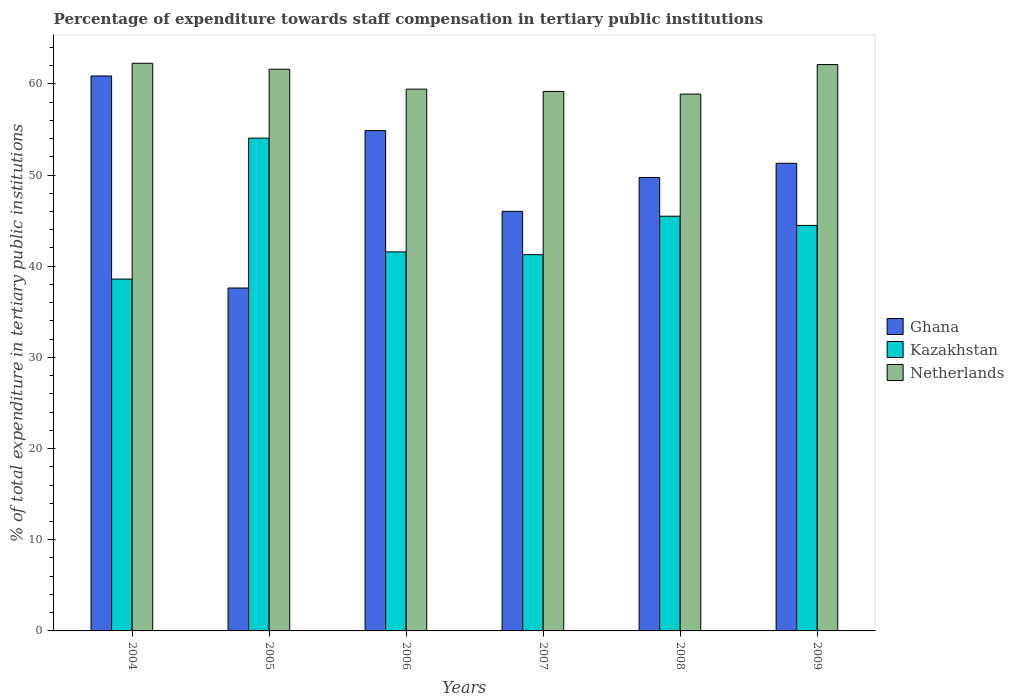How many different coloured bars are there?
Ensure brevity in your answer.  3. How many groups of bars are there?
Ensure brevity in your answer.  6. Are the number of bars on each tick of the X-axis equal?
Ensure brevity in your answer.  Yes. How many bars are there on the 4th tick from the left?
Provide a succinct answer. 3. What is the label of the 3rd group of bars from the left?
Provide a succinct answer. 2006. In how many cases, is the number of bars for a given year not equal to the number of legend labels?
Offer a very short reply. 0. What is the percentage of expenditure towards staff compensation in Kazakhstan in 2006?
Your response must be concise. 41.57. Across all years, what is the maximum percentage of expenditure towards staff compensation in Kazakhstan?
Your answer should be very brief. 54.05. Across all years, what is the minimum percentage of expenditure towards staff compensation in Netherlands?
Keep it short and to the point. 58.88. In which year was the percentage of expenditure towards staff compensation in Netherlands maximum?
Ensure brevity in your answer.  2004. In which year was the percentage of expenditure towards staff compensation in Ghana minimum?
Your response must be concise. 2005. What is the total percentage of expenditure towards staff compensation in Kazakhstan in the graph?
Your answer should be very brief. 265.43. What is the difference between the percentage of expenditure towards staff compensation in Netherlands in 2006 and that in 2007?
Make the answer very short. 0.26. What is the difference between the percentage of expenditure towards staff compensation in Kazakhstan in 2005 and the percentage of expenditure towards staff compensation in Netherlands in 2006?
Your answer should be very brief. -5.37. What is the average percentage of expenditure towards staff compensation in Kazakhstan per year?
Your answer should be compact. 44.24. In the year 2004, what is the difference between the percentage of expenditure towards staff compensation in Netherlands and percentage of expenditure towards staff compensation in Kazakhstan?
Your answer should be very brief. 23.67. What is the ratio of the percentage of expenditure towards staff compensation in Netherlands in 2004 to that in 2008?
Give a very brief answer. 1.06. Is the percentage of expenditure towards staff compensation in Kazakhstan in 2007 less than that in 2009?
Your answer should be compact. Yes. Is the difference between the percentage of expenditure towards staff compensation in Netherlands in 2007 and 2009 greater than the difference between the percentage of expenditure towards staff compensation in Kazakhstan in 2007 and 2009?
Provide a short and direct response. Yes. What is the difference between the highest and the second highest percentage of expenditure towards staff compensation in Ghana?
Your response must be concise. 5.99. What is the difference between the highest and the lowest percentage of expenditure towards staff compensation in Kazakhstan?
Provide a short and direct response. 15.46. Is the sum of the percentage of expenditure towards staff compensation in Kazakhstan in 2004 and 2008 greater than the maximum percentage of expenditure towards staff compensation in Netherlands across all years?
Provide a succinct answer. Yes. What does the 3rd bar from the left in 2005 represents?
Provide a succinct answer. Netherlands. What does the 1st bar from the right in 2005 represents?
Give a very brief answer. Netherlands. How many bars are there?
Provide a short and direct response. 18. Are all the bars in the graph horizontal?
Ensure brevity in your answer.  No. Does the graph contain grids?
Your response must be concise. No. Where does the legend appear in the graph?
Provide a short and direct response. Center right. How are the legend labels stacked?
Keep it short and to the point. Vertical. What is the title of the graph?
Provide a succinct answer. Percentage of expenditure towards staff compensation in tertiary public institutions. Does "Monaco" appear as one of the legend labels in the graph?
Ensure brevity in your answer.  No. What is the label or title of the Y-axis?
Ensure brevity in your answer.  % of total expenditure in tertiary public institutions. What is the % of total expenditure in tertiary public institutions of Ghana in 2004?
Provide a short and direct response. 60.86. What is the % of total expenditure in tertiary public institutions of Kazakhstan in 2004?
Offer a very short reply. 38.59. What is the % of total expenditure in tertiary public institutions in Netherlands in 2004?
Keep it short and to the point. 62.26. What is the % of total expenditure in tertiary public institutions of Ghana in 2005?
Give a very brief answer. 37.61. What is the % of total expenditure in tertiary public institutions in Kazakhstan in 2005?
Provide a succinct answer. 54.05. What is the % of total expenditure in tertiary public institutions in Netherlands in 2005?
Your answer should be compact. 61.6. What is the % of total expenditure in tertiary public institutions in Ghana in 2006?
Your answer should be very brief. 54.87. What is the % of total expenditure in tertiary public institutions of Kazakhstan in 2006?
Your response must be concise. 41.57. What is the % of total expenditure in tertiary public institutions of Netherlands in 2006?
Keep it short and to the point. 59.42. What is the % of total expenditure in tertiary public institutions of Ghana in 2007?
Provide a succinct answer. 46.02. What is the % of total expenditure in tertiary public institutions of Kazakhstan in 2007?
Offer a terse response. 41.27. What is the % of total expenditure in tertiary public institutions in Netherlands in 2007?
Keep it short and to the point. 59.17. What is the % of total expenditure in tertiary public institutions in Ghana in 2008?
Your answer should be compact. 49.73. What is the % of total expenditure in tertiary public institutions in Kazakhstan in 2008?
Provide a short and direct response. 45.48. What is the % of total expenditure in tertiary public institutions of Netherlands in 2008?
Give a very brief answer. 58.88. What is the % of total expenditure in tertiary public institutions in Ghana in 2009?
Provide a succinct answer. 51.29. What is the % of total expenditure in tertiary public institutions of Kazakhstan in 2009?
Offer a very short reply. 44.48. What is the % of total expenditure in tertiary public institutions in Netherlands in 2009?
Provide a succinct answer. 62.12. Across all years, what is the maximum % of total expenditure in tertiary public institutions of Ghana?
Ensure brevity in your answer.  60.86. Across all years, what is the maximum % of total expenditure in tertiary public institutions of Kazakhstan?
Give a very brief answer. 54.05. Across all years, what is the maximum % of total expenditure in tertiary public institutions in Netherlands?
Give a very brief answer. 62.26. Across all years, what is the minimum % of total expenditure in tertiary public institutions in Ghana?
Provide a succinct answer. 37.61. Across all years, what is the minimum % of total expenditure in tertiary public institutions in Kazakhstan?
Keep it short and to the point. 38.59. Across all years, what is the minimum % of total expenditure in tertiary public institutions in Netherlands?
Offer a very short reply. 58.88. What is the total % of total expenditure in tertiary public institutions of Ghana in the graph?
Give a very brief answer. 300.39. What is the total % of total expenditure in tertiary public institutions in Kazakhstan in the graph?
Your answer should be very brief. 265.43. What is the total % of total expenditure in tertiary public institutions in Netherlands in the graph?
Your response must be concise. 363.44. What is the difference between the % of total expenditure in tertiary public institutions in Ghana in 2004 and that in 2005?
Your response must be concise. 23.25. What is the difference between the % of total expenditure in tertiary public institutions of Kazakhstan in 2004 and that in 2005?
Give a very brief answer. -15.46. What is the difference between the % of total expenditure in tertiary public institutions in Netherlands in 2004 and that in 2005?
Give a very brief answer. 0.66. What is the difference between the % of total expenditure in tertiary public institutions of Ghana in 2004 and that in 2006?
Your answer should be very brief. 5.99. What is the difference between the % of total expenditure in tertiary public institutions of Kazakhstan in 2004 and that in 2006?
Provide a succinct answer. -2.98. What is the difference between the % of total expenditure in tertiary public institutions of Netherlands in 2004 and that in 2006?
Provide a short and direct response. 2.84. What is the difference between the % of total expenditure in tertiary public institutions of Ghana in 2004 and that in 2007?
Your answer should be very brief. 14.85. What is the difference between the % of total expenditure in tertiary public institutions in Kazakhstan in 2004 and that in 2007?
Make the answer very short. -2.68. What is the difference between the % of total expenditure in tertiary public institutions of Netherlands in 2004 and that in 2007?
Your response must be concise. 3.09. What is the difference between the % of total expenditure in tertiary public institutions in Ghana in 2004 and that in 2008?
Offer a very short reply. 11.14. What is the difference between the % of total expenditure in tertiary public institutions of Kazakhstan in 2004 and that in 2008?
Keep it short and to the point. -6.89. What is the difference between the % of total expenditure in tertiary public institutions of Netherlands in 2004 and that in 2008?
Your answer should be very brief. 3.38. What is the difference between the % of total expenditure in tertiary public institutions in Ghana in 2004 and that in 2009?
Make the answer very short. 9.57. What is the difference between the % of total expenditure in tertiary public institutions of Kazakhstan in 2004 and that in 2009?
Provide a succinct answer. -5.89. What is the difference between the % of total expenditure in tertiary public institutions in Netherlands in 2004 and that in 2009?
Offer a very short reply. 0.14. What is the difference between the % of total expenditure in tertiary public institutions in Ghana in 2005 and that in 2006?
Make the answer very short. -17.26. What is the difference between the % of total expenditure in tertiary public institutions in Kazakhstan in 2005 and that in 2006?
Your answer should be compact. 12.48. What is the difference between the % of total expenditure in tertiary public institutions of Netherlands in 2005 and that in 2006?
Keep it short and to the point. 2.18. What is the difference between the % of total expenditure in tertiary public institutions of Ghana in 2005 and that in 2007?
Keep it short and to the point. -8.4. What is the difference between the % of total expenditure in tertiary public institutions of Kazakhstan in 2005 and that in 2007?
Your response must be concise. 12.78. What is the difference between the % of total expenditure in tertiary public institutions in Netherlands in 2005 and that in 2007?
Keep it short and to the point. 2.44. What is the difference between the % of total expenditure in tertiary public institutions in Ghana in 2005 and that in 2008?
Offer a terse response. -12.12. What is the difference between the % of total expenditure in tertiary public institutions of Kazakhstan in 2005 and that in 2008?
Offer a very short reply. 8.57. What is the difference between the % of total expenditure in tertiary public institutions in Netherlands in 2005 and that in 2008?
Your answer should be compact. 2.73. What is the difference between the % of total expenditure in tertiary public institutions in Ghana in 2005 and that in 2009?
Keep it short and to the point. -13.68. What is the difference between the % of total expenditure in tertiary public institutions of Kazakhstan in 2005 and that in 2009?
Offer a very short reply. 9.57. What is the difference between the % of total expenditure in tertiary public institutions in Netherlands in 2005 and that in 2009?
Provide a short and direct response. -0.51. What is the difference between the % of total expenditure in tertiary public institutions in Ghana in 2006 and that in 2007?
Your answer should be very brief. 8.86. What is the difference between the % of total expenditure in tertiary public institutions in Kazakhstan in 2006 and that in 2007?
Keep it short and to the point. 0.3. What is the difference between the % of total expenditure in tertiary public institutions in Netherlands in 2006 and that in 2007?
Give a very brief answer. 0.26. What is the difference between the % of total expenditure in tertiary public institutions in Ghana in 2006 and that in 2008?
Offer a very short reply. 5.14. What is the difference between the % of total expenditure in tertiary public institutions of Kazakhstan in 2006 and that in 2008?
Provide a short and direct response. -3.92. What is the difference between the % of total expenditure in tertiary public institutions in Netherlands in 2006 and that in 2008?
Your answer should be compact. 0.54. What is the difference between the % of total expenditure in tertiary public institutions of Ghana in 2006 and that in 2009?
Offer a very short reply. 3.58. What is the difference between the % of total expenditure in tertiary public institutions of Kazakhstan in 2006 and that in 2009?
Make the answer very short. -2.91. What is the difference between the % of total expenditure in tertiary public institutions of Netherlands in 2006 and that in 2009?
Keep it short and to the point. -2.7. What is the difference between the % of total expenditure in tertiary public institutions of Ghana in 2007 and that in 2008?
Offer a very short reply. -3.71. What is the difference between the % of total expenditure in tertiary public institutions of Kazakhstan in 2007 and that in 2008?
Provide a short and direct response. -4.22. What is the difference between the % of total expenditure in tertiary public institutions of Netherlands in 2007 and that in 2008?
Provide a short and direct response. 0.29. What is the difference between the % of total expenditure in tertiary public institutions in Ghana in 2007 and that in 2009?
Your answer should be very brief. -5.27. What is the difference between the % of total expenditure in tertiary public institutions of Kazakhstan in 2007 and that in 2009?
Offer a terse response. -3.21. What is the difference between the % of total expenditure in tertiary public institutions in Netherlands in 2007 and that in 2009?
Offer a terse response. -2.95. What is the difference between the % of total expenditure in tertiary public institutions of Ghana in 2008 and that in 2009?
Give a very brief answer. -1.56. What is the difference between the % of total expenditure in tertiary public institutions in Kazakhstan in 2008 and that in 2009?
Your response must be concise. 1.01. What is the difference between the % of total expenditure in tertiary public institutions of Netherlands in 2008 and that in 2009?
Provide a short and direct response. -3.24. What is the difference between the % of total expenditure in tertiary public institutions of Ghana in 2004 and the % of total expenditure in tertiary public institutions of Kazakhstan in 2005?
Your answer should be very brief. 6.82. What is the difference between the % of total expenditure in tertiary public institutions of Ghana in 2004 and the % of total expenditure in tertiary public institutions of Netherlands in 2005?
Ensure brevity in your answer.  -0.74. What is the difference between the % of total expenditure in tertiary public institutions of Kazakhstan in 2004 and the % of total expenditure in tertiary public institutions of Netherlands in 2005?
Provide a short and direct response. -23.01. What is the difference between the % of total expenditure in tertiary public institutions in Ghana in 2004 and the % of total expenditure in tertiary public institutions in Kazakhstan in 2006?
Your response must be concise. 19.3. What is the difference between the % of total expenditure in tertiary public institutions of Ghana in 2004 and the % of total expenditure in tertiary public institutions of Netherlands in 2006?
Your answer should be compact. 1.44. What is the difference between the % of total expenditure in tertiary public institutions of Kazakhstan in 2004 and the % of total expenditure in tertiary public institutions of Netherlands in 2006?
Your response must be concise. -20.83. What is the difference between the % of total expenditure in tertiary public institutions of Ghana in 2004 and the % of total expenditure in tertiary public institutions of Kazakhstan in 2007?
Provide a short and direct response. 19.6. What is the difference between the % of total expenditure in tertiary public institutions of Ghana in 2004 and the % of total expenditure in tertiary public institutions of Netherlands in 2007?
Your answer should be compact. 1.7. What is the difference between the % of total expenditure in tertiary public institutions of Kazakhstan in 2004 and the % of total expenditure in tertiary public institutions of Netherlands in 2007?
Offer a terse response. -20.58. What is the difference between the % of total expenditure in tertiary public institutions in Ghana in 2004 and the % of total expenditure in tertiary public institutions in Kazakhstan in 2008?
Offer a very short reply. 15.38. What is the difference between the % of total expenditure in tertiary public institutions of Ghana in 2004 and the % of total expenditure in tertiary public institutions of Netherlands in 2008?
Give a very brief answer. 1.99. What is the difference between the % of total expenditure in tertiary public institutions in Kazakhstan in 2004 and the % of total expenditure in tertiary public institutions in Netherlands in 2008?
Keep it short and to the point. -20.29. What is the difference between the % of total expenditure in tertiary public institutions of Ghana in 2004 and the % of total expenditure in tertiary public institutions of Kazakhstan in 2009?
Ensure brevity in your answer.  16.39. What is the difference between the % of total expenditure in tertiary public institutions in Ghana in 2004 and the % of total expenditure in tertiary public institutions in Netherlands in 2009?
Your response must be concise. -1.25. What is the difference between the % of total expenditure in tertiary public institutions in Kazakhstan in 2004 and the % of total expenditure in tertiary public institutions in Netherlands in 2009?
Provide a short and direct response. -23.53. What is the difference between the % of total expenditure in tertiary public institutions of Ghana in 2005 and the % of total expenditure in tertiary public institutions of Kazakhstan in 2006?
Make the answer very short. -3.96. What is the difference between the % of total expenditure in tertiary public institutions in Ghana in 2005 and the % of total expenditure in tertiary public institutions in Netherlands in 2006?
Offer a terse response. -21.81. What is the difference between the % of total expenditure in tertiary public institutions in Kazakhstan in 2005 and the % of total expenditure in tertiary public institutions in Netherlands in 2006?
Offer a terse response. -5.37. What is the difference between the % of total expenditure in tertiary public institutions in Ghana in 2005 and the % of total expenditure in tertiary public institutions in Kazakhstan in 2007?
Offer a very short reply. -3.65. What is the difference between the % of total expenditure in tertiary public institutions in Ghana in 2005 and the % of total expenditure in tertiary public institutions in Netherlands in 2007?
Offer a very short reply. -21.55. What is the difference between the % of total expenditure in tertiary public institutions in Kazakhstan in 2005 and the % of total expenditure in tertiary public institutions in Netherlands in 2007?
Offer a terse response. -5.12. What is the difference between the % of total expenditure in tertiary public institutions in Ghana in 2005 and the % of total expenditure in tertiary public institutions in Kazakhstan in 2008?
Your response must be concise. -7.87. What is the difference between the % of total expenditure in tertiary public institutions in Ghana in 2005 and the % of total expenditure in tertiary public institutions in Netherlands in 2008?
Give a very brief answer. -21.27. What is the difference between the % of total expenditure in tertiary public institutions in Kazakhstan in 2005 and the % of total expenditure in tertiary public institutions in Netherlands in 2008?
Provide a short and direct response. -4.83. What is the difference between the % of total expenditure in tertiary public institutions in Ghana in 2005 and the % of total expenditure in tertiary public institutions in Kazakhstan in 2009?
Offer a terse response. -6.86. What is the difference between the % of total expenditure in tertiary public institutions in Ghana in 2005 and the % of total expenditure in tertiary public institutions in Netherlands in 2009?
Provide a succinct answer. -24.51. What is the difference between the % of total expenditure in tertiary public institutions of Kazakhstan in 2005 and the % of total expenditure in tertiary public institutions of Netherlands in 2009?
Your answer should be very brief. -8.07. What is the difference between the % of total expenditure in tertiary public institutions of Ghana in 2006 and the % of total expenditure in tertiary public institutions of Kazakhstan in 2007?
Offer a terse response. 13.61. What is the difference between the % of total expenditure in tertiary public institutions in Ghana in 2006 and the % of total expenditure in tertiary public institutions in Netherlands in 2007?
Keep it short and to the point. -4.29. What is the difference between the % of total expenditure in tertiary public institutions of Kazakhstan in 2006 and the % of total expenditure in tertiary public institutions of Netherlands in 2007?
Offer a very short reply. -17.6. What is the difference between the % of total expenditure in tertiary public institutions in Ghana in 2006 and the % of total expenditure in tertiary public institutions in Kazakhstan in 2008?
Give a very brief answer. 9.39. What is the difference between the % of total expenditure in tertiary public institutions in Ghana in 2006 and the % of total expenditure in tertiary public institutions in Netherlands in 2008?
Offer a very short reply. -4. What is the difference between the % of total expenditure in tertiary public institutions of Kazakhstan in 2006 and the % of total expenditure in tertiary public institutions of Netherlands in 2008?
Your answer should be compact. -17.31. What is the difference between the % of total expenditure in tertiary public institutions in Ghana in 2006 and the % of total expenditure in tertiary public institutions in Kazakhstan in 2009?
Ensure brevity in your answer.  10.4. What is the difference between the % of total expenditure in tertiary public institutions of Ghana in 2006 and the % of total expenditure in tertiary public institutions of Netherlands in 2009?
Provide a short and direct response. -7.24. What is the difference between the % of total expenditure in tertiary public institutions of Kazakhstan in 2006 and the % of total expenditure in tertiary public institutions of Netherlands in 2009?
Make the answer very short. -20.55. What is the difference between the % of total expenditure in tertiary public institutions of Ghana in 2007 and the % of total expenditure in tertiary public institutions of Kazakhstan in 2008?
Your answer should be very brief. 0.53. What is the difference between the % of total expenditure in tertiary public institutions of Ghana in 2007 and the % of total expenditure in tertiary public institutions of Netherlands in 2008?
Make the answer very short. -12.86. What is the difference between the % of total expenditure in tertiary public institutions of Kazakhstan in 2007 and the % of total expenditure in tertiary public institutions of Netherlands in 2008?
Provide a short and direct response. -17.61. What is the difference between the % of total expenditure in tertiary public institutions of Ghana in 2007 and the % of total expenditure in tertiary public institutions of Kazakhstan in 2009?
Offer a very short reply. 1.54. What is the difference between the % of total expenditure in tertiary public institutions of Ghana in 2007 and the % of total expenditure in tertiary public institutions of Netherlands in 2009?
Provide a short and direct response. -16.1. What is the difference between the % of total expenditure in tertiary public institutions of Kazakhstan in 2007 and the % of total expenditure in tertiary public institutions of Netherlands in 2009?
Provide a short and direct response. -20.85. What is the difference between the % of total expenditure in tertiary public institutions in Ghana in 2008 and the % of total expenditure in tertiary public institutions in Kazakhstan in 2009?
Your response must be concise. 5.25. What is the difference between the % of total expenditure in tertiary public institutions in Ghana in 2008 and the % of total expenditure in tertiary public institutions in Netherlands in 2009?
Your answer should be very brief. -12.39. What is the difference between the % of total expenditure in tertiary public institutions in Kazakhstan in 2008 and the % of total expenditure in tertiary public institutions in Netherlands in 2009?
Make the answer very short. -16.63. What is the average % of total expenditure in tertiary public institutions in Ghana per year?
Provide a succinct answer. 50.06. What is the average % of total expenditure in tertiary public institutions in Kazakhstan per year?
Provide a succinct answer. 44.24. What is the average % of total expenditure in tertiary public institutions in Netherlands per year?
Offer a terse response. 60.57. In the year 2004, what is the difference between the % of total expenditure in tertiary public institutions in Ghana and % of total expenditure in tertiary public institutions in Kazakhstan?
Keep it short and to the point. 22.28. In the year 2004, what is the difference between the % of total expenditure in tertiary public institutions of Ghana and % of total expenditure in tertiary public institutions of Netherlands?
Make the answer very short. -1.39. In the year 2004, what is the difference between the % of total expenditure in tertiary public institutions of Kazakhstan and % of total expenditure in tertiary public institutions of Netherlands?
Provide a short and direct response. -23.67. In the year 2005, what is the difference between the % of total expenditure in tertiary public institutions in Ghana and % of total expenditure in tertiary public institutions in Kazakhstan?
Provide a short and direct response. -16.44. In the year 2005, what is the difference between the % of total expenditure in tertiary public institutions in Ghana and % of total expenditure in tertiary public institutions in Netherlands?
Ensure brevity in your answer.  -23.99. In the year 2005, what is the difference between the % of total expenditure in tertiary public institutions in Kazakhstan and % of total expenditure in tertiary public institutions in Netherlands?
Ensure brevity in your answer.  -7.55. In the year 2006, what is the difference between the % of total expenditure in tertiary public institutions of Ghana and % of total expenditure in tertiary public institutions of Kazakhstan?
Your answer should be compact. 13.31. In the year 2006, what is the difference between the % of total expenditure in tertiary public institutions in Ghana and % of total expenditure in tertiary public institutions in Netherlands?
Offer a very short reply. -4.55. In the year 2006, what is the difference between the % of total expenditure in tertiary public institutions in Kazakhstan and % of total expenditure in tertiary public institutions in Netherlands?
Your response must be concise. -17.85. In the year 2007, what is the difference between the % of total expenditure in tertiary public institutions in Ghana and % of total expenditure in tertiary public institutions in Kazakhstan?
Provide a short and direct response. 4.75. In the year 2007, what is the difference between the % of total expenditure in tertiary public institutions in Ghana and % of total expenditure in tertiary public institutions in Netherlands?
Ensure brevity in your answer.  -13.15. In the year 2007, what is the difference between the % of total expenditure in tertiary public institutions of Kazakhstan and % of total expenditure in tertiary public institutions of Netherlands?
Provide a succinct answer. -17.9. In the year 2008, what is the difference between the % of total expenditure in tertiary public institutions in Ghana and % of total expenditure in tertiary public institutions in Kazakhstan?
Keep it short and to the point. 4.25. In the year 2008, what is the difference between the % of total expenditure in tertiary public institutions in Ghana and % of total expenditure in tertiary public institutions in Netherlands?
Your answer should be compact. -9.15. In the year 2008, what is the difference between the % of total expenditure in tertiary public institutions in Kazakhstan and % of total expenditure in tertiary public institutions in Netherlands?
Your response must be concise. -13.39. In the year 2009, what is the difference between the % of total expenditure in tertiary public institutions of Ghana and % of total expenditure in tertiary public institutions of Kazakhstan?
Ensure brevity in your answer.  6.81. In the year 2009, what is the difference between the % of total expenditure in tertiary public institutions of Ghana and % of total expenditure in tertiary public institutions of Netherlands?
Give a very brief answer. -10.83. In the year 2009, what is the difference between the % of total expenditure in tertiary public institutions of Kazakhstan and % of total expenditure in tertiary public institutions of Netherlands?
Provide a short and direct response. -17.64. What is the ratio of the % of total expenditure in tertiary public institutions in Ghana in 2004 to that in 2005?
Provide a succinct answer. 1.62. What is the ratio of the % of total expenditure in tertiary public institutions in Kazakhstan in 2004 to that in 2005?
Your answer should be compact. 0.71. What is the ratio of the % of total expenditure in tertiary public institutions of Netherlands in 2004 to that in 2005?
Give a very brief answer. 1.01. What is the ratio of the % of total expenditure in tertiary public institutions in Ghana in 2004 to that in 2006?
Your response must be concise. 1.11. What is the ratio of the % of total expenditure in tertiary public institutions of Kazakhstan in 2004 to that in 2006?
Give a very brief answer. 0.93. What is the ratio of the % of total expenditure in tertiary public institutions of Netherlands in 2004 to that in 2006?
Provide a succinct answer. 1.05. What is the ratio of the % of total expenditure in tertiary public institutions of Ghana in 2004 to that in 2007?
Ensure brevity in your answer.  1.32. What is the ratio of the % of total expenditure in tertiary public institutions of Kazakhstan in 2004 to that in 2007?
Make the answer very short. 0.94. What is the ratio of the % of total expenditure in tertiary public institutions of Netherlands in 2004 to that in 2007?
Ensure brevity in your answer.  1.05. What is the ratio of the % of total expenditure in tertiary public institutions in Ghana in 2004 to that in 2008?
Your response must be concise. 1.22. What is the ratio of the % of total expenditure in tertiary public institutions in Kazakhstan in 2004 to that in 2008?
Your answer should be compact. 0.85. What is the ratio of the % of total expenditure in tertiary public institutions of Netherlands in 2004 to that in 2008?
Keep it short and to the point. 1.06. What is the ratio of the % of total expenditure in tertiary public institutions of Ghana in 2004 to that in 2009?
Offer a terse response. 1.19. What is the ratio of the % of total expenditure in tertiary public institutions in Kazakhstan in 2004 to that in 2009?
Offer a very short reply. 0.87. What is the ratio of the % of total expenditure in tertiary public institutions in Ghana in 2005 to that in 2006?
Your answer should be very brief. 0.69. What is the ratio of the % of total expenditure in tertiary public institutions of Kazakhstan in 2005 to that in 2006?
Offer a terse response. 1.3. What is the ratio of the % of total expenditure in tertiary public institutions of Netherlands in 2005 to that in 2006?
Make the answer very short. 1.04. What is the ratio of the % of total expenditure in tertiary public institutions in Ghana in 2005 to that in 2007?
Give a very brief answer. 0.82. What is the ratio of the % of total expenditure in tertiary public institutions in Kazakhstan in 2005 to that in 2007?
Provide a short and direct response. 1.31. What is the ratio of the % of total expenditure in tertiary public institutions of Netherlands in 2005 to that in 2007?
Your answer should be compact. 1.04. What is the ratio of the % of total expenditure in tertiary public institutions in Ghana in 2005 to that in 2008?
Make the answer very short. 0.76. What is the ratio of the % of total expenditure in tertiary public institutions in Kazakhstan in 2005 to that in 2008?
Provide a succinct answer. 1.19. What is the ratio of the % of total expenditure in tertiary public institutions in Netherlands in 2005 to that in 2008?
Give a very brief answer. 1.05. What is the ratio of the % of total expenditure in tertiary public institutions of Ghana in 2005 to that in 2009?
Keep it short and to the point. 0.73. What is the ratio of the % of total expenditure in tertiary public institutions in Kazakhstan in 2005 to that in 2009?
Offer a very short reply. 1.22. What is the ratio of the % of total expenditure in tertiary public institutions of Ghana in 2006 to that in 2007?
Keep it short and to the point. 1.19. What is the ratio of the % of total expenditure in tertiary public institutions in Kazakhstan in 2006 to that in 2007?
Keep it short and to the point. 1.01. What is the ratio of the % of total expenditure in tertiary public institutions of Ghana in 2006 to that in 2008?
Provide a short and direct response. 1.1. What is the ratio of the % of total expenditure in tertiary public institutions in Kazakhstan in 2006 to that in 2008?
Your answer should be very brief. 0.91. What is the ratio of the % of total expenditure in tertiary public institutions of Netherlands in 2006 to that in 2008?
Provide a short and direct response. 1.01. What is the ratio of the % of total expenditure in tertiary public institutions of Ghana in 2006 to that in 2009?
Offer a very short reply. 1.07. What is the ratio of the % of total expenditure in tertiary public institutions in Kazakhstan in 2006 to that in 2009?
Give a very brief answer. 0.93. What is the ratio of the % of total expenditure in tertiary public institutions of Netherlands in 2006 to that in 2009?
Make the answer very short. 0.96. What is the ratio of the % of total expenditure in tertiary public institutions in Ghana in 2007 to that in 2008?
Give a very brief answer. 0.93. What is the ratio of the % of total expenditure in tertiary public institutions of Kazakhstan in 2007 to that in 2008?
Give a very brief answer. 0.91. What is the ratio of the % of total expenditure in tertiary public institutions in Ghana in 2007 to that in 2009?
Provide a succinct answer. 0.9. What is the ratio of the % of total expenditure in tertiary public institutions in Kazakhstan in 2007 to that in 2009?
Your answer should be compact. 0.93. What is the ratio of the % of total expenditure in tertiary public institutions of Netherlands in 2007 to that in 2009?
Your answer should be very brief. 0.95. What is the ratio of the % of total expenditure in tertiary public institutions in Ghana in 2008 to that in 2009?
Make the answer very short. 0.97. What is the ratio of the % of total expenditure in tertiary public institutions in Kazakhstan in 2008 to that in 2009?
Your response must be concise. 1.02. What is the ratio of the % of total expenditure in tertiary public institutions in Netherlands in 2008 to that in 2009?
Offer a terse response. 0.95. What is the difference between the highest and the second highest % of total expenditure in tertiary public institutions in Ghana?
Ensure brevity in your answer.  5.99. What is the difference between the highest and the second highest % of total expenditure in tertiary public institutions of Kazakhstan?
Give a very brief answer. 8.57. What is the difference between the highest and the second highest % of total expenditure in tertiary public institutions of Netherlands?
Your answer should be compact. 0.14. What is the difference between the highest and the lowest % of total expenditure in tertiary public institutions in Ghana?
Provide a succinct answer. 23.25. What is the difference between the highest and the lowest % of total expenditure in tertiary public institutions in Kazakhstan?
Provide a short and direct response. 15.46. What is the difference between the highest and the lowest % of total expenditure in tertiary public institutions of Netherlands?
Your response must be concise. 3.38. 